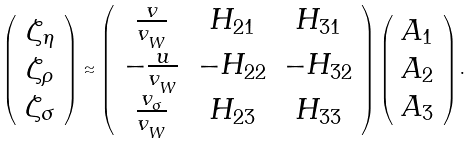<formula> <loc_0><loc_0><loc_500><loc_500>\left ( \begin{array} { c } \zeta _ { \eta } \\ \zeta _ { \rho } \\ \zeta _ { \sigma } \end{array} \right ) \approx \left ( \begin{array} { c c c } \frac { v } { v _ { _ { W } } } & H _ { 2 1 } & H _ { 3 1 } \\ - \frac { u } { v _ { _ { W } } } & - H _ { 2 2 } & - H _ { 3 2 } \\ \frac { v _ { _ { \sigma } } } { v _ { _ { W } } } & H _ { 2 3 } & H _ { 3 3 } \end{array} \right ) \left ( \begin{array} { c } A _ { 1 } \\ A _ { 2 } \\ A _ { 3 } \end{array} \right ) .</formula> 